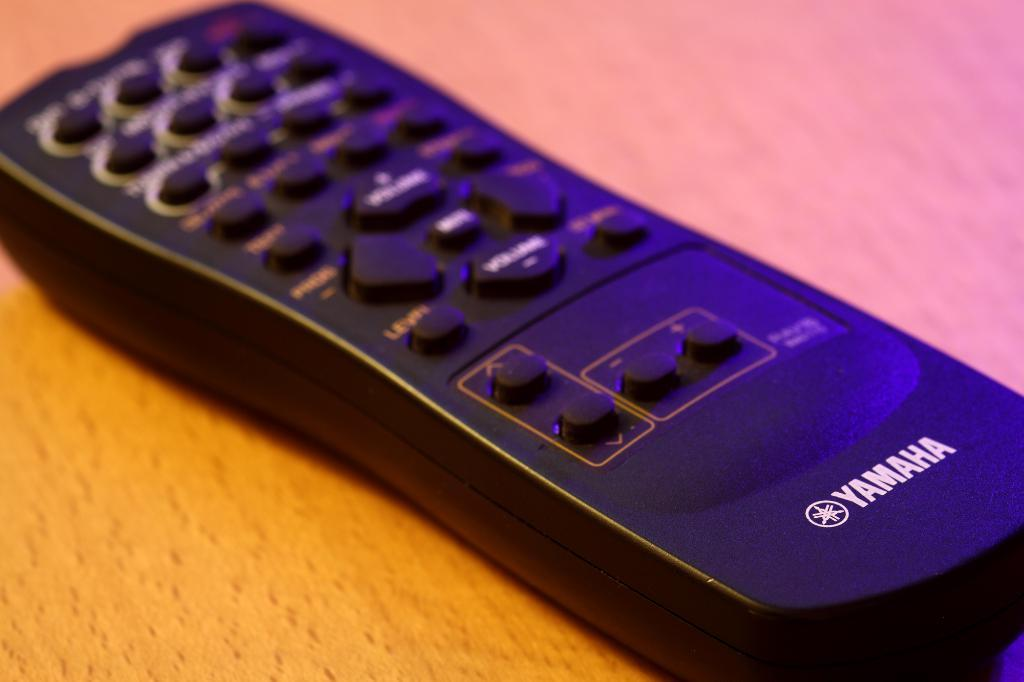<image>
Provide a brief description of the given image. A Yamaha television remote is placed on a tabletop. 